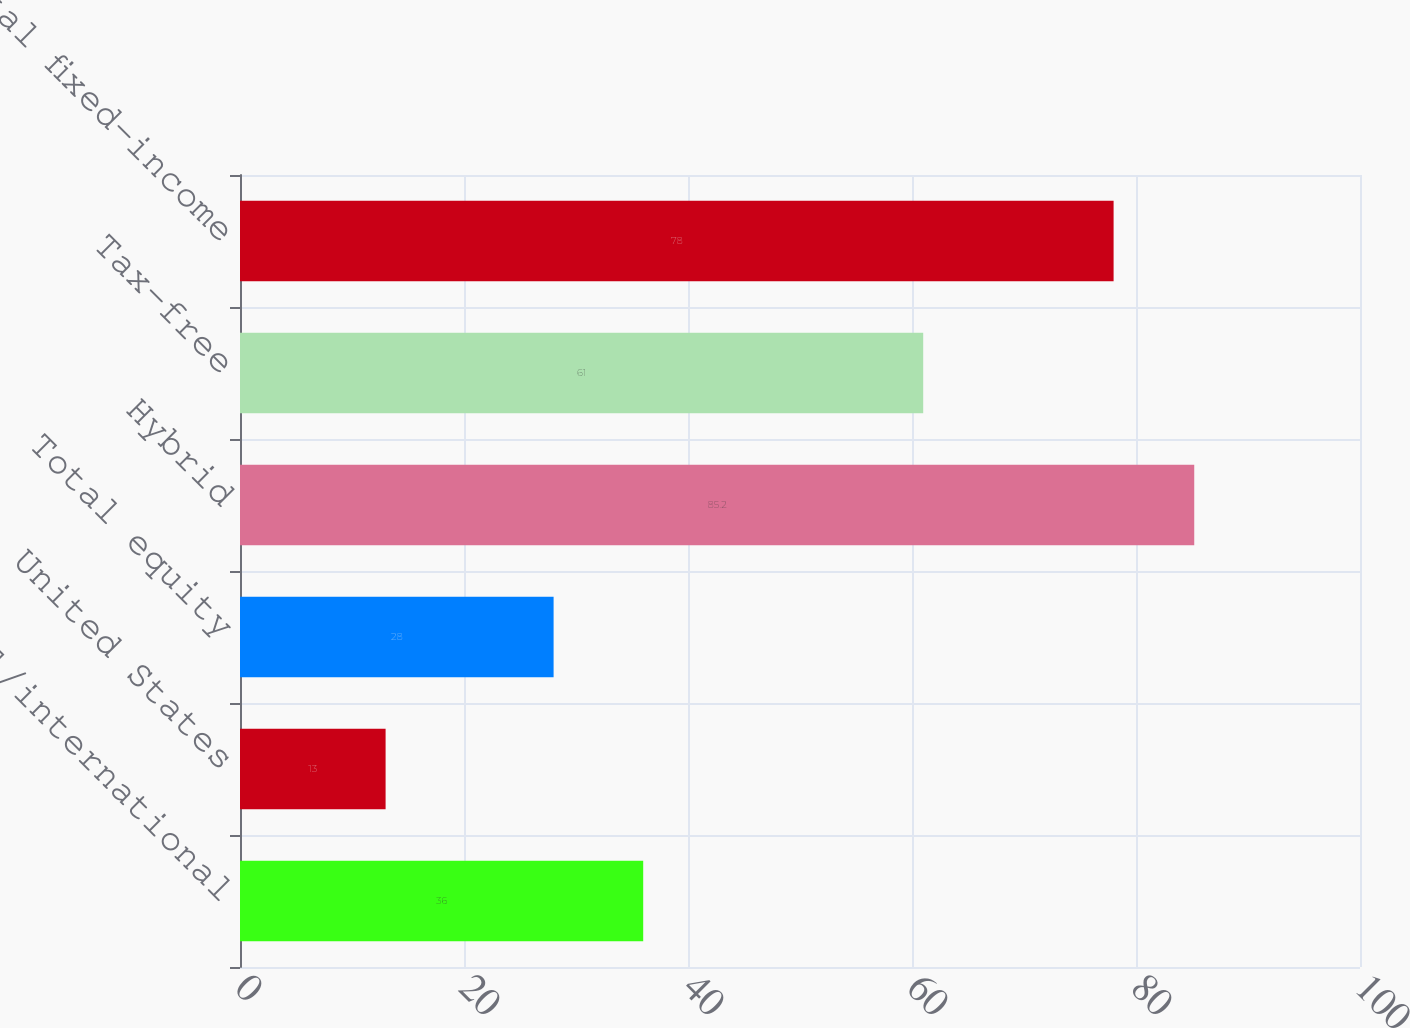Convert chart. <chart><loc_0><loc_0><loc_500><loc_500><bar_chart><fcel>Global/international<fcel>United States<fcel>Total equity<fcel>Hybrid<fcel>Tax-free<fcel>Total fixed-income<nl><fcel>36<fcel>13<fcel>28<fcel>85.2<fcel>61<fcel>78<nl></chart> 